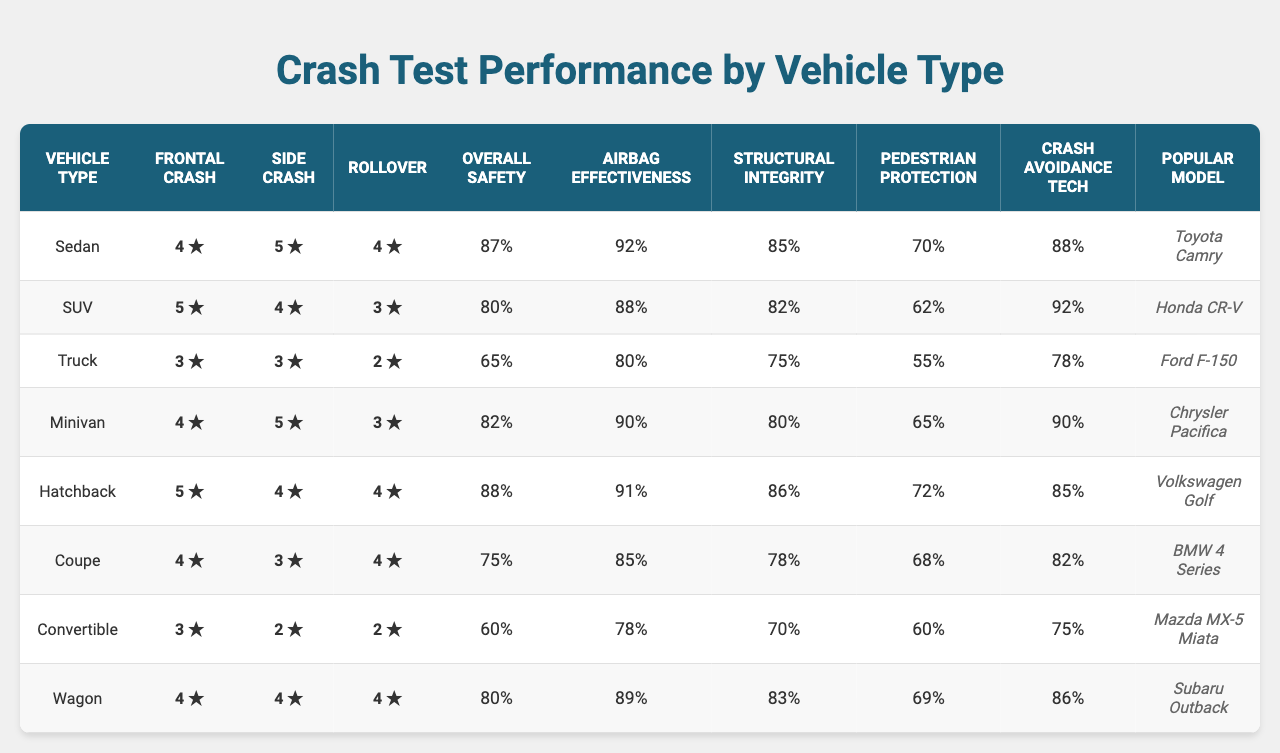What is the frontal crash rating of an SUV? From the table, the frontal crash rating for the vehicle type "SUV" is listed as 5.
Answer: 5 Which vehicle type has the lowest rollover rating? The rollover ratings in the table show that "Truck" has the lowest rating of 2.
Answer: Truck What is the overall safety score for the Sedan? The overall safety score for the vehicle type "Sedan" is given as 87 in the table.
Answer: 87 Which vehicle types have a pedestrian protection score higher than 70? Looking at the pedestrian protection scores, "Sedan," "Hatchback," and "Minivan" are the only types above 70, with scores of 70, 72, and 65 respectively.
Answer: Sedan, Hatchback What is the average overall safety score of all vehicle types? The safety scores are: 87, 80, 65, 82, 88, 75, 60, 80. Adding them gives 87 + 80 + 65 + 82 + 88 + 75 + 60 + 80 = 637. Dividing by 8 vehicle types gives an average of 79.625, which rounds approximately to 80.
Answer: 80 Is the airbag effectiveness score for Trucks higher than for Sedans? The airbag effectiveness score for Trucks is 80, while for Sedans it is 92, which is higher. Hence, the statement is false.
Answer: No Which vehicle type has the highest side crash rating, and what is the rating? Searching through the side crash rating, we see that "Sedan" has the highest rating of 5.
Answer: Sedan, 5 If we order the vehicle types by overall safety score from highest to lowest, what are the top three types? The overall safety scores in descending order are: Hatchback (88), Sedan (87), and Minivan (82). Thus, the top three are: Hatchback, Sedan, Minivan.
Answer: Hatchback, Sedan, Minivan What is the difference between the highest and lowest airbag effectiveness scores? The highest airbag effectiveness score is 92 (Sedan), and the lowest is 78 (Convertible). Thus, the difference is 92 - 78 = 14.
Answer: 14 Which vehicle type has the worst structural integrity score? The structural integrity score for "Convertible" is the lowest at 70, according to the table.
Answer: Convertible 